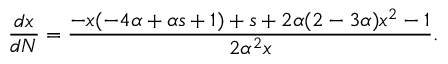Convert formula to latex. <formula><loc_0><loc_0><loc_500><loc_500>\frac { d x } { d N } = \frac { - x ( - 4 \alpha + \alpha s + 1 ) + s + 2 \alpha ( 2 - 3 \alpha ) x ^ { 2 } - 1 } { 2 \alpha ^ { 2 } x } .</formula> 